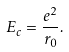<formula> <loc_0><loc_0><loc_500><loc_500>E _ { c } = \frac { e ^ { 2 } } { r _ { 0 } } .</formula> 